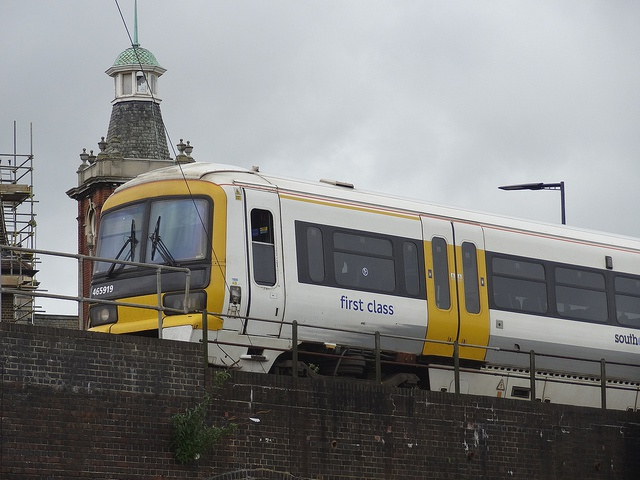Describe the objects in this image and their specific colors. I can see a train in darkgray, gray, black, and lightgray tones in this image. 